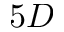Convert formula to latex. <formula><loc_0><loc_0><loc_500><loc_500>5 D</formula> 